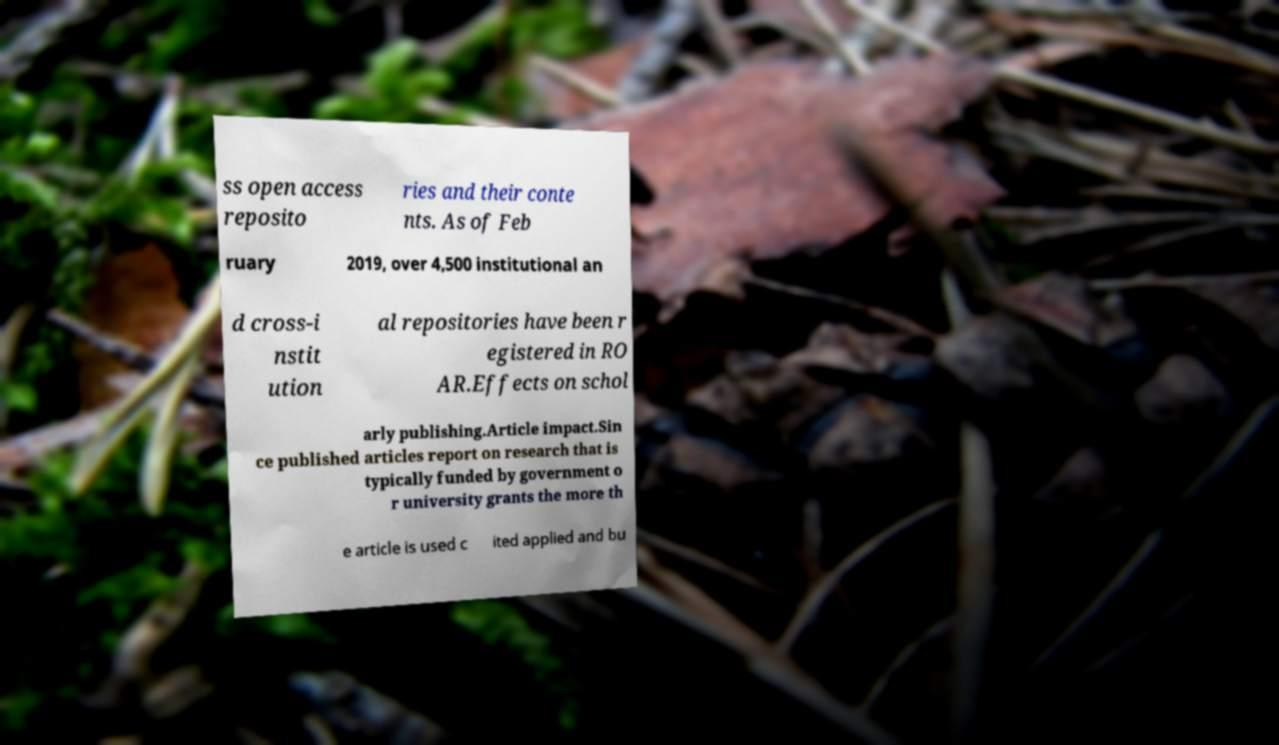Can you accurately transcribe the text from the provided image for me? ss open access reposito ries and their conte nts. As of Feb ruary 2019, over 4,500 institutional an d cross-i nstit ution al repositories have been r egistered in RO AR.Effects on schol arly publishing.Article impact.Sin ce published articles report on research that is typically funded by government o r university grants the more th e article is used c ited applied and bu 